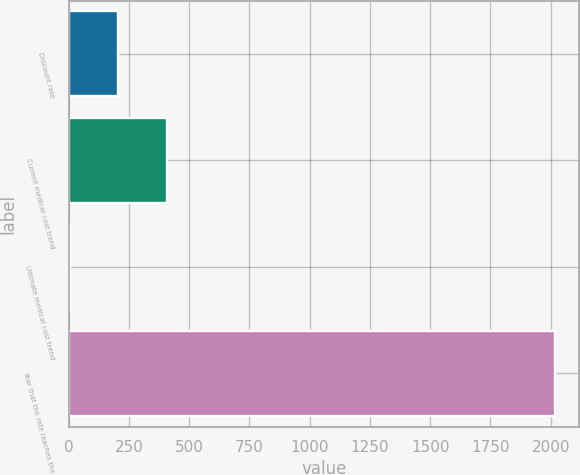Convert chart to OTSL. <chart><loc_0><loc_0><loc_500><loc_500><bar_chart><fcel>Discount rate<fcel>Current medical cost trend<fcel>Ultimate medical cost trend<fcel>Year that the rate reaches the<nl><fcel>206.1<fcel>407.2<fcel>5<fcel>2016<nl></chart> 